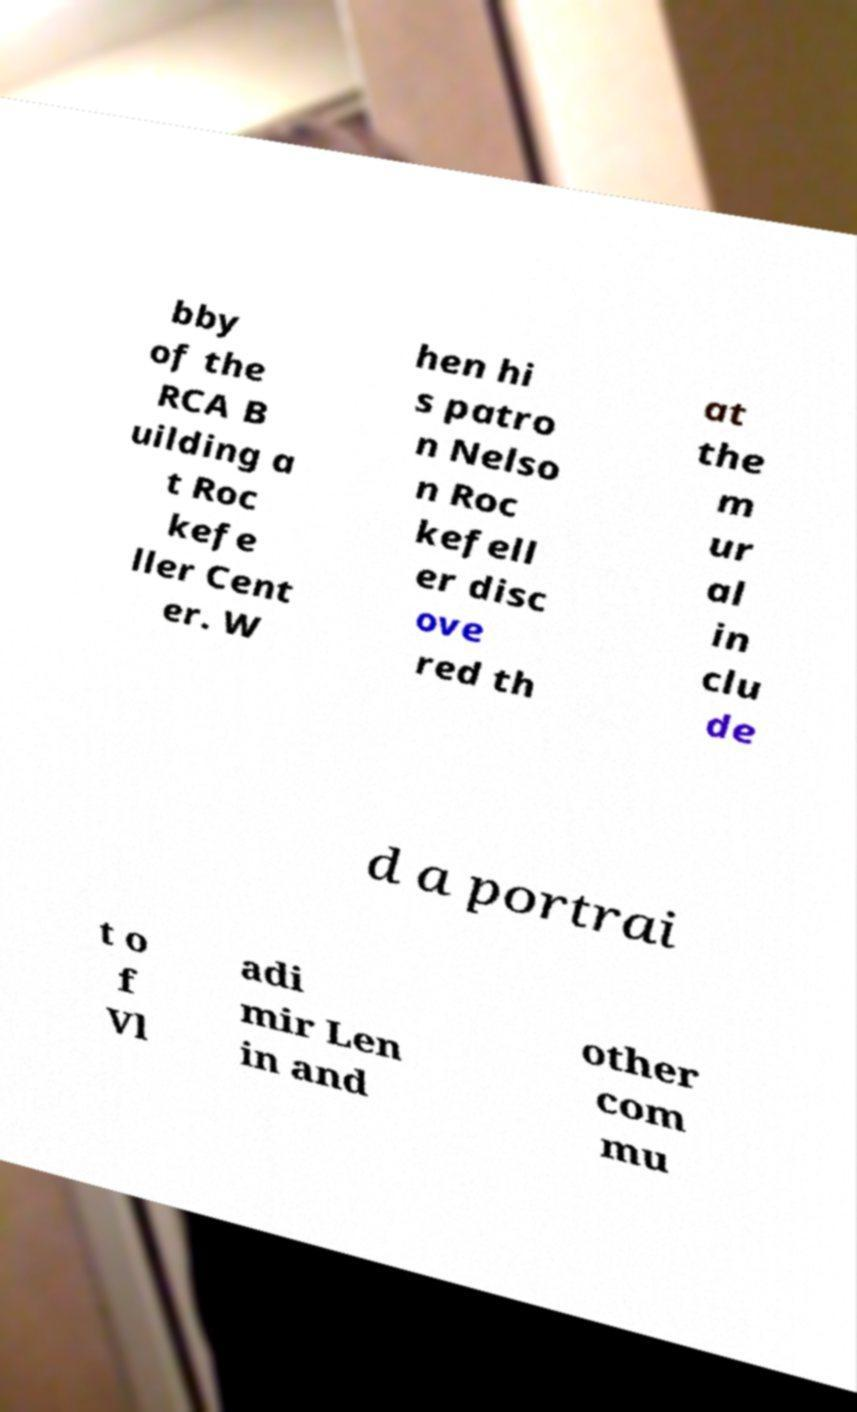I need the written content from this picture converted into text. Can you do that? bby of the RCA B uilding a t Roc kefe ller Cent er. W hen hi s patro n Nelso n Roc kefell er disc ove red th at the m ur al in clu de d a portrai t o f Vl adi mir Len in and other com mu 